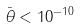<formula> <loc_0><loc_0><loc_500><loc_500>\bar { \theta } < 1 0 ^ { - 1 0 }</formula> 